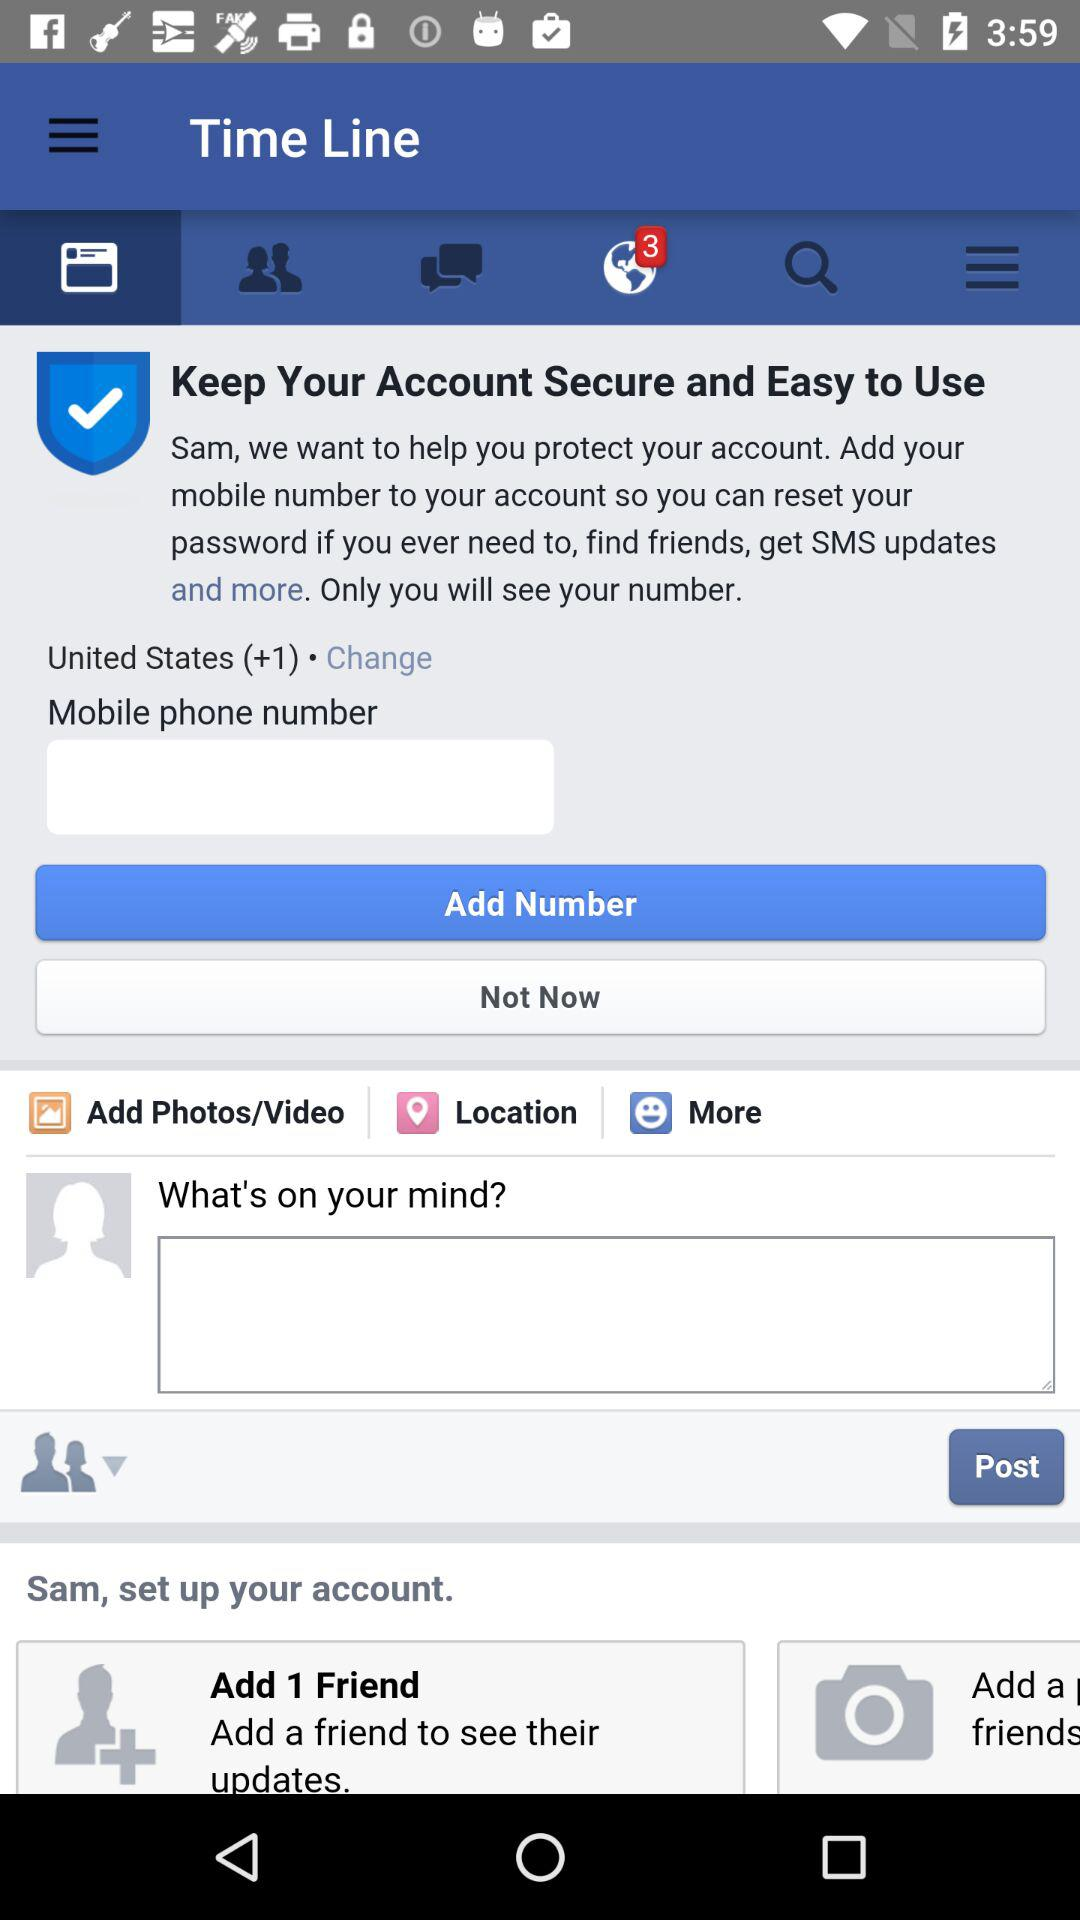What is the name of the user? The name of the user is Sam. 